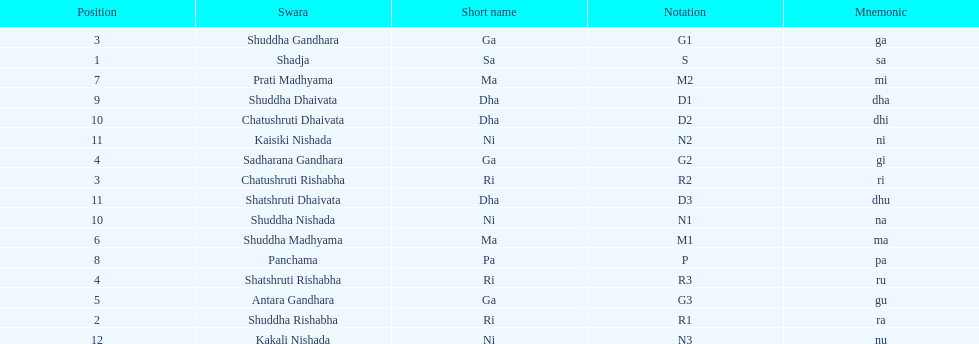How many swaras do not have dhaivata in their name? 13. 